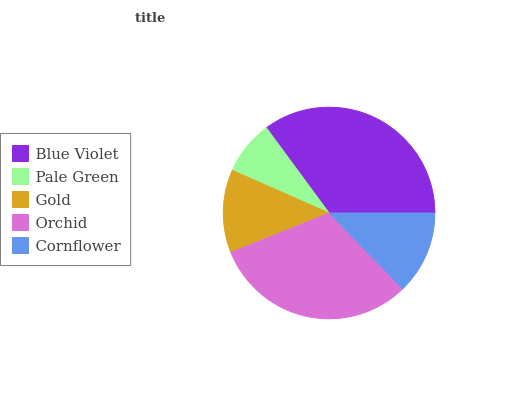Is Pale Green the minimum?
Answer yes or no. Yes. Is Blue Violet the maximum?
Answer yes or no. Yes. Is Gold the minimum?
Answer yes or no. No. Is Gold the maximum?
Answer yes or no. No. Is Gold greater than Pale Green?
Answer yes or no. Yes. Is Pale Green less than Gold?
Answer yes or no. Yes. Is Pale Green greater than Gold?
Answer yes or no. No. Is Gold less than Pale Green?
Answer yes or no. No. Is Cornflower the high median?
Answer yes or no. Yes. Is Cornflower the low median?
Answer yes or no. Yes. Is Pale Green the high median?
Answer yes or no. No. Is Blue Violet the low median?
Answer yes or no. No. 